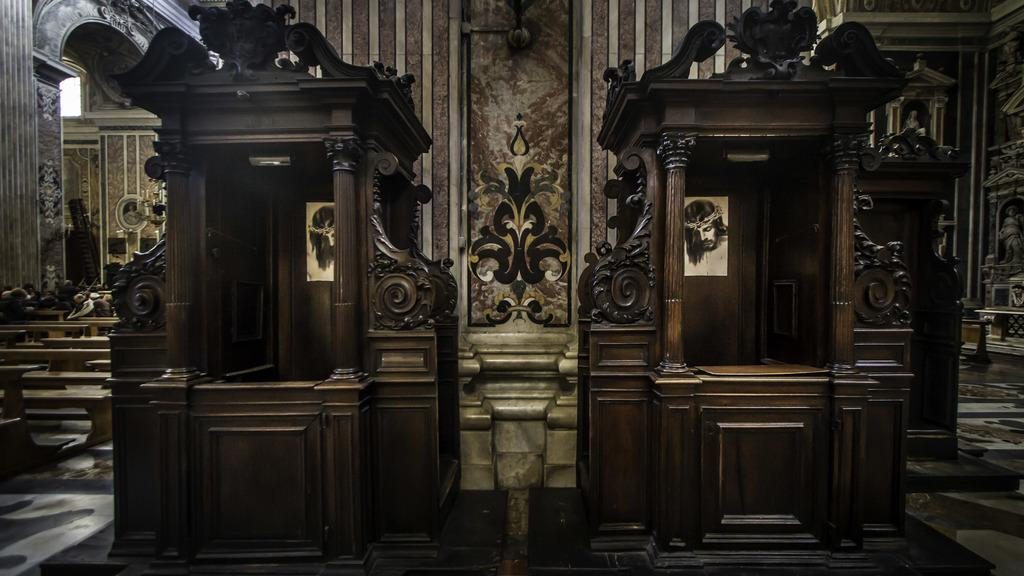What type of structures can be seen in the image? There are alters, benches, statues, an arch, and a wall visible in the image. What type of flooring is present in the image? There is flooring in the image. What architectural feature can be seen in the image that provides a view of the outside? There is a window in the image. Can you see the cat playing with friends near the watch in the image? There is no cat or watch present in the image. 